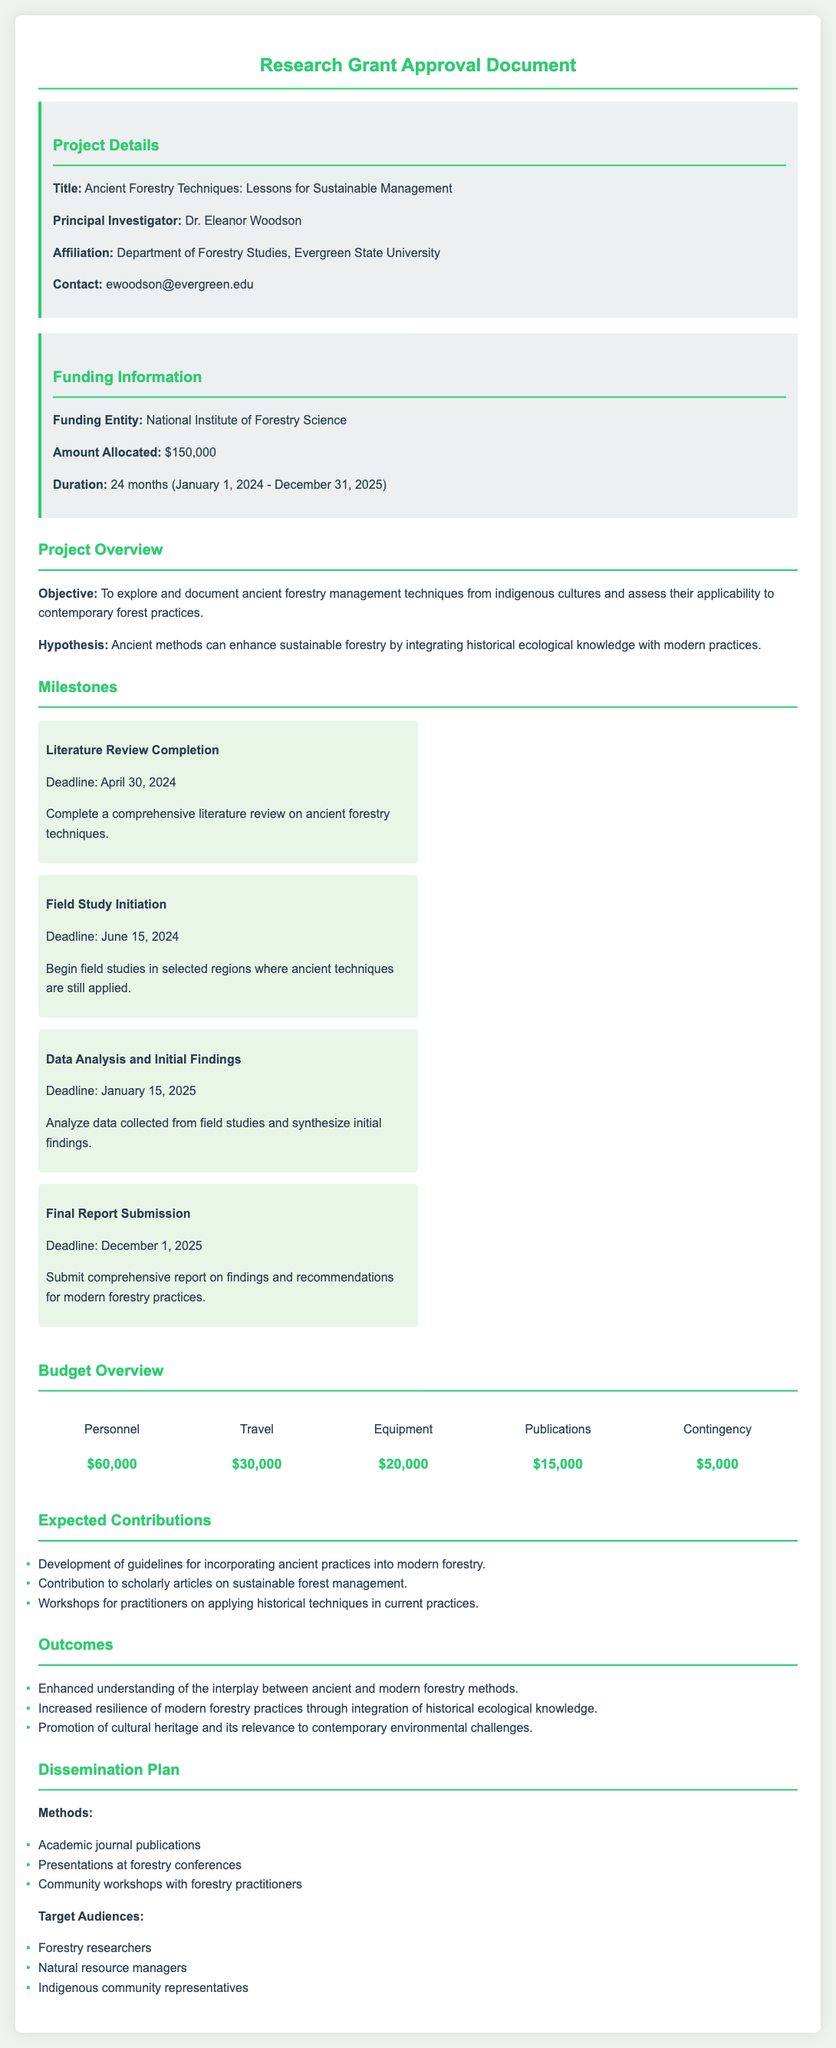What is the title of the project? The project's title is stated clearly in the document under Project Details, which is "Ancient Forestry Techniques: Lessons for Sustainable Management."
Answer: Ancient Forestry Techniques: Lessons for Sustainable Management Who is the Principal Investigator? The document specifies the Principal Investigator as Dr. Eleanor Woodson in the Project Details section.
Answer: Dr. Eleanor Woodson What is the total budget allocated for the project? The budget allocation is mentioned in the Funding Information section of the document, amounting to $150,000.
Answer: $150,000 When is the Final Report Submission deadline? The deadline for the Final Report Submission is listed under the Milestones section, specifically noted as December 1, 2025.
Answer: December 1, 2025 What percentage of the budget is allocated to Personnel? Personnel receives $60,000 out of the total budget of $150,000, which is 40%. This requires calculating the fraction of Personnel in relation to the total budget.
Answer: 40% What is the main objective of the project? The objective of the project is provided in the Project Overview section, which states that it aims to explore and document ancient forestry management techniques.
Answer: Explore and document ancient forestry management techniques What are the expected contributions mentioned in the document? The document outlines several expected contributions, one of which includes the development of guidelines for incorporating ancient practices into modern forestry.
Answer: Development of guidelines for incorporating ancient practices into modern forestry How long is the duration of the funding? The duration mentioned in the Funding Information section is 24 months, starting from January 1, 2024 to December 31, 2025.
Answer: 24 months Which entity is providing the funding? The funding entity is listed in the Funding Information section of the document as the National Institute of Forestry Science.
Answer: National Institute of Forestry Science 